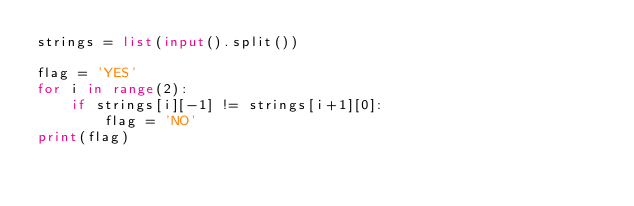<code> <loc_0><loc_0><loc_500><loc_500><_Python_>strings = list(input().split())

flag = 'YES'
for i in range(2):
    if strings[i][-1] != strings[i+1][0]:
        flag = 'NO'
print(flag)</code> 